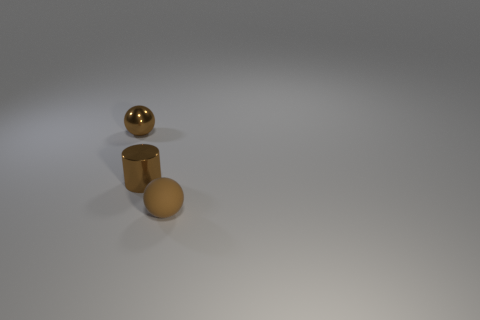What number of things are either balls on the left side of the small cylinder or cylinders that are right of the tiny brown shiny sphere?
Your response must be concise. 2. The tiny brown thing that is the same material as the tiny cylinder is what shape?
Offer a terse response. Sphere. How many other things are there of the same size as the brown metallic cylinder?
Ensure brevity in your answer.  2. What material is the tiny brown cylinder?
Give a very brief answer. Metal. Are there more brown rubber spheres to the right of the tiny metallic sphere than big red balls?
Ensure brevity in your answer.  Yes. Is there a rubber ball?
Your answer should be compact. Yes. What number of other things are the same shape as the matte thing?
Ensure brevity in your answer.  1. Does the metallic object in front of the metallic sphere have the same color as the metal object that is on the left side of the small brown cylinder?
Ensure brevity in your answer.  Yes. What is the size of the brown sphere behind the brown ball on the right side of the brown ball that is to the left of the metallic cylinder?
Make the answer very short. Small. What is the shape of the small brown object that is in front of the brown metal sphere and left of the tiny brown rubber thing?
Ensure brevity in your answer.  Cylinder. 